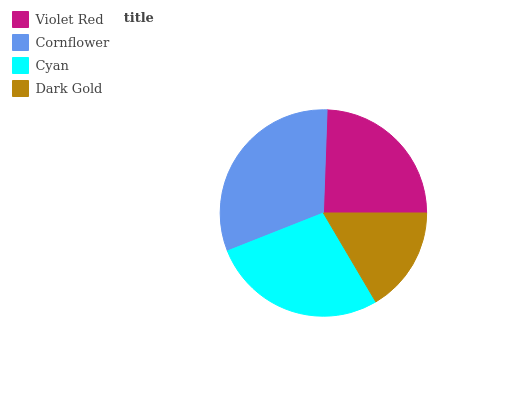Is Dark Gold the minimum?
Answer yes or no. Yes. Is Cornflower the maximum?
Answer yes or no. Yes. Is Cyan the minimum?
Answer yes or no. No. Is Cyan the maximum?
Answer yes or no. No. Is Cornflower greater than Cyan?
Answer yes or no. Yes. Is Cyan less than Cornflower?
Answer yes or no. Yes. Is Cyan greater than Cornflower?
Answer yes or no. No. Is Cornflower less than Cyan?
Answer yes or no. No. Is Cyan the high median?
Answer yes or no. Yes. Is Violet Red the low median?
Answer yes or no. Yes. Is Dark Gold the high median?
Answer yes or no. No. Is Cornflower the low median?
Answer yes or no. No. 